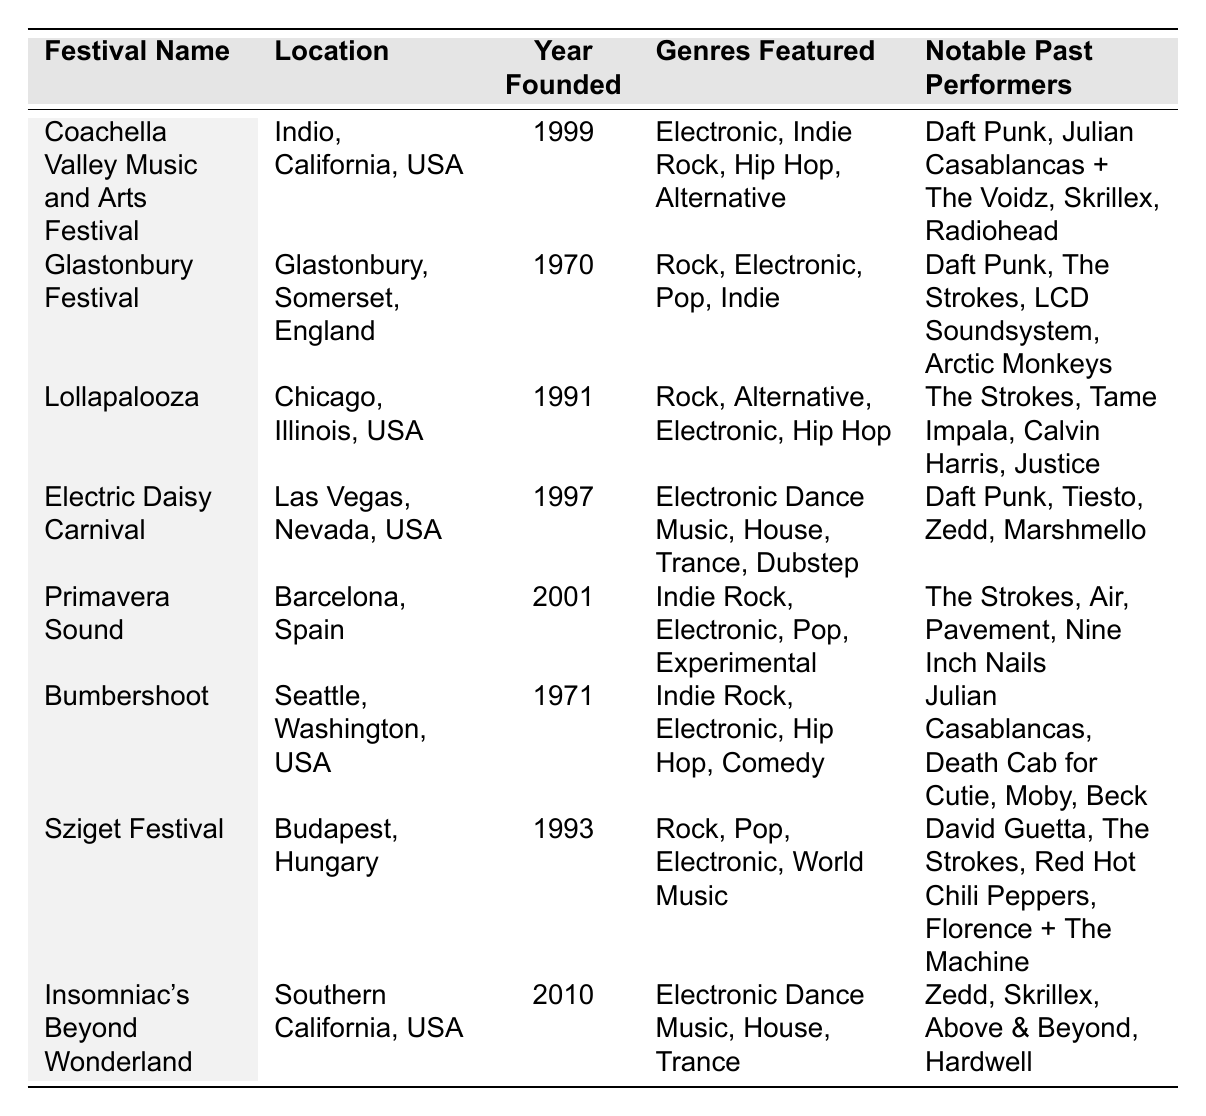What is the location of the Coachella Valley Music and Arts Festival? The table shows that the Coachella Valley Music and Arts Festival is located in Indio, California, USA.
Answer: Indio, California, USA How many genres are featured at the Electric Daisy Carnival? The table lists four genres featured at the Electric Daisy Carnival: Electronic Dance Music, House, Trance, and Dubstep.
Answer: Four Did Julian Casablancas perform at Bumbershoot? According to the table, Julian Casablancas is indeed listed as a notable past performer at Bumbershoot.
Answer: Yes Which festival was founded first, Glastonbury Festival or Lollapalooza? The Glastonbury Festival was founded in 1970, while Lollapalooza was founded in 1991. Since 1970 is earlier than 1991, Glastonbury Festival was founded first.
Answer: Glastonbury Festival How many festivals have featured Daft Punk? Daft Punk is mentioned as a notable past performer in three festivals: Coachella Valley Music and Arts Festival, Glastonbury Festival, and Electric Daisy Carnival.
Answer: Three Which festival has the latest founding year, and who performed there? Insomniac's Beyond Wonderland has the latest founding year of 2010, and notable performers listed are Zedd, Skrillex, Above & Beyond, and Hardwell.
Answer: Insomniac's Beyond Wonderland; Zedd, Skrillex, Above & Beyond, Hardwell Can you name one festival that features Indie Rock and Electronic music? Primavera Sound and Coachella Valley Music and Arts Festival both feature Indie Rock and Electronic genres. Thus, either can be an answer.
Answer: Primavera Sound (or Coachella Valley Music and Arts Festival) How many festivals feature the genre "Hip Hop"? The table shows that Coachella Valley Music and Arts Festival, Lollapalooza, and Bumbershoot all feature Hip Hop as one of their genres, resulting in three festivals.
Answer: Three What is the earliest festival listed, and how many notable past performers does it have? The earliest festival is Glastonbury Festival, founded in 1970. It has four notable past performers: Daft Punk, The Strokes, LCD Soundsystem, and Arctic Monkeys.
Answer: Glastonbury Festival; Four If you combine the years founded of Bumbershoot and Sziget Festival, what is the total? Bumbershoot was founded in 1971, and Sziget Festival in 1993. Adding these gives 1971 + 1993 = 3964.
Answer: 3964 